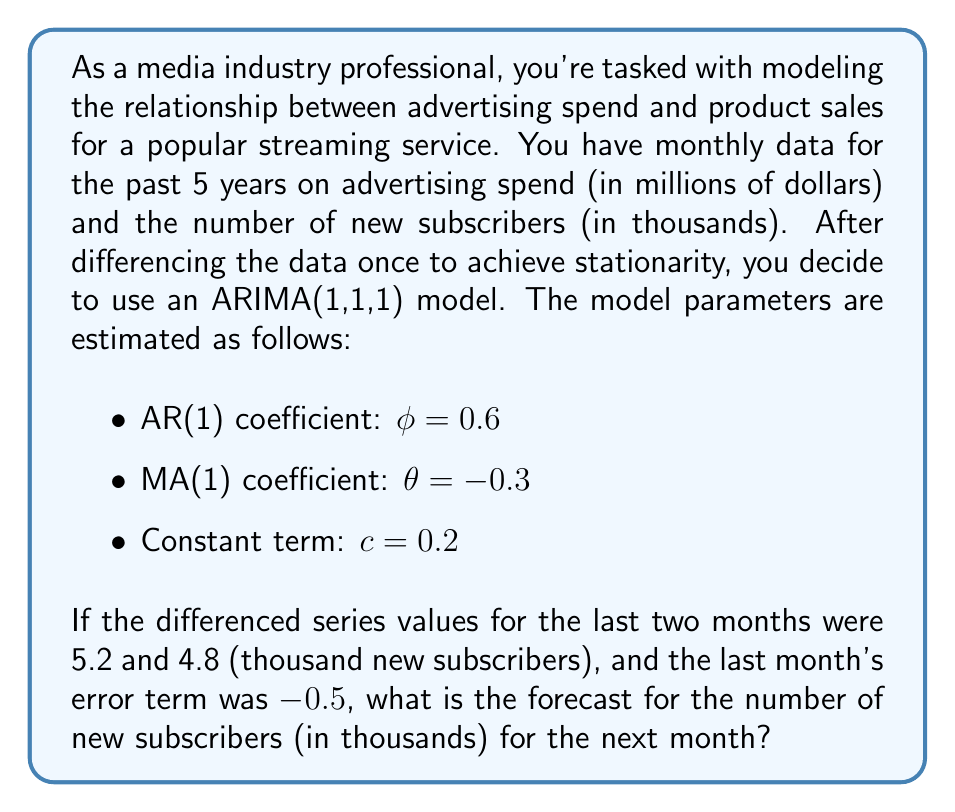Teach me how to tackle this problem. To solve this problem, we need to use the ARIMA(1,1,1) model equation and the given information. Let's break it down step by step:

1) The general form of an ARIMA(1,1,1) model for the differenced series $y_t$ is:

   $y_t = c + \phi y_{t-1} + \theta \varepsilon_{t-1} + \varepsilon_t$

   where $y_t$ is the differenced series at time $t$, $c$ is the constant term, $\phi$ is the AR(1) coefficient, $\theta$ is the MA(1) coefficient, and $\varepsilon_t$ is the error term at time $t$.

2) We are given:
   $\phi = 0.6$
   $\theta = -0.3$
   $c = 0.2$
   $y_{t-1} = 4.8$ (last month's differenced value)
   $y_{t-2} = 5.2$ (second-to-last month's differenced value)
   $\varepsilon_{t-1} = -0.5$ (last month's error term)

3) Plugging these values into the equation:

   $y_t = 0.2 + 0.6(4.8) + (-0.3)(-0.5) + \varepsilon_t$

4) Simplifying:

   $y_t = 0.2 + 2.88 + 0.15 + \varepsilon_t = 3.23 + \varepsilon_t$

5) Since we're forecasting, we set the future error term $\varepsilon_t = 0$ (its expected value):

   $\hat{y_t} = 3.23$

6) However, this is the forecast for the differenced series. To get the actual forecast, we need to "undifference" the series:

   $\text{Forecast} = \text{Last actual value} + \hat{y_t}$

7) The last actual value isn't given directly, but we can calculate it:
   Last actual value = Second-to-last actual value + $y_{t-1}$
                     = (Second-to-last actual value + $y_{t-2}$) + $y_{t-1}$
                     = X + 5.2 + 4.8
                     = X + 10

Therefore, the forecast for the next month is: $(X + 10) + 3.23 = X + 13.23$

Where X is the actual number of new subscribers two months ago.
Answer: The forecast for the number of new subscribers for the next month is X + 13.23 thousand, where X is the actual number of new subscribers two months ago. 